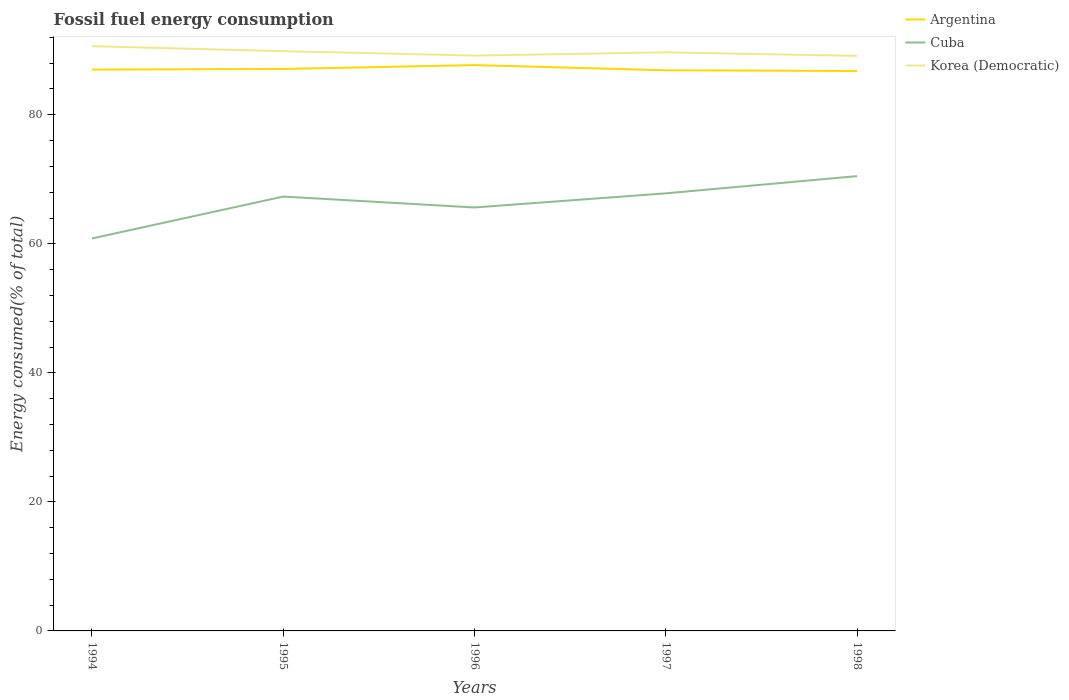Across all years, what is the maximum percentage of energy consumed in Cuba?
Offer a terse response. 60.83. What is the total percentage of energy consumed in Cuba in the graph?
Make the answer very short. -2.19. What is the difference between the highest and the second highest percentage of energy consumed in Korea (Democratic)?
Offer a terse response. 1.5. How many lines are there?
Provide a short and direct response. 3. How many legend labels are there?
Offer a very short reply. 3. What is the title of the graph?
Make the answer very short. Fossil fuel energy consumption. What is the label or title of the Y-axis?
Provide a short and direct response. Energy consumed(% of total). What is the Energy consumed(% of total) in Argentina in 1994?
Your answer should be very brief. 87.01. What is the Energy consumed(% of total) of Cuba in 1994?
Offer a terse response. 60.83. What is the Energy consumed(% of total) in Korea (Democratic) in 1994?
Make the answer very short. 90.63. What is the Energy consumed(% of total) in Argentina in 1995?
Provide a succinct answer. 87.1. What is the Energy consumed(% of total) of Cuba in 1995?
Ensure brevity in your answer.  67.32. What is the Energy consumed(% of total) of Korea (Democratic) in 1995?
Your answer should be compact. 89.86. What is the Energy consumed(% of total) in Argentina in 1996?
Your answer should be very brief. 87.7. What is the Energy consumed(% of total) in Cuba in 1996?
Offer a terse response. 65.63. What is the Energy consumed(% of total) of Korea (Democratic) in 1996?
Keep it short and to the point. 89.17. What is the Energy consumed(% of total) in Argentina in 1997?
Offer a terse response. 86.9. What is the Energy consumed(% of total) in Cuba in 1997?
Provide a succinct answer. 67.83. What is the Energy consumed(% of total) in Korea (Democratic) in 1997?
Offer a terse response. 89.68. What is the Energy consumed(% of total) of Argentina in 1998?
Your answer should be very brief. 86.79. What is the Energy consumed(% of total) of Cuba in 1998?
Give a very brief answer. 70.49. What is the Energy consumed(% of total) in Korea (Democratic) in 1998?
Provide a short and direct response. 89.13. Across all years, what is the maximum Energy consumed(% of total) in Argentina?
Your answer should be very brief. 87.7. Across all years, what is the maximum Energy consumed(% of total) of Cuba?
Offer a terse response. 70.49. Across all years, what is the maximum Energy consumed(% of total) in Korea (Democratic)?
Provide a succinct answer. 90.63. Across all years, what is the minimum Energy consumed(% of total) in Argentina?
Ensure brevity in your answer.  86.79. Across all years, what is the minimum Energy consumed(% of total) in Cuba?
Offer a very short reply. 60.83. Across all years, what is the minimum Energy consumed(% of total) in Korea (Democratic)?
Keep it short and to the point. 89.13. What is the total Energy consumed(% of total) of Argentina in the graph?
Your answer should be very brief. 435.5. What is the total Energy consumed(% of total) in Cuba in the graph?
Make the answer very short. 332.11. What is the total Energy consumed(% of total) in Korea (Democratic) in the graph?
Offer a very short reply. 448.48. What is the difference between the Energy consumed(% of total) in Argentina in 1994 and that in 1995?
Your answer should be compact. -0.09. What is the difference between the Energy consumed(% of total) in Cuba in 1994 and that in 1995?
Keep it short and to the point. -6.49. What is the difference between the Energy consumed(% of total) of Korea (Democratic) in 1994 and that in 1995?
Give a very brief answer. 0.77. What is the difference between the Energy consumed(% of total) in Argentina in 1994 and that in 1996?
Ensure brevity in your answer.  -0.69. What is the difference between the Energy consumed(% of total) of Cuba in 1994 and that in 1996?
Offer a very short reply. -4.8. What is the difference between the Energy consumed(% of total) of Korea (Democratic) in 1994 and that in 1996?
Offer a terse response. 1.46. What is the difference between the Energy consumed(% of total) in Argentina in 1994 and that in 1997?
Your answer should be very brief. 0.11. What is the difference between the Energy consumed(% of total) of Cuba in 1994 and that in 1997?
Ensure brevity in your answer.  -6.99. What is the difference between the Energy consumed(% of total) of Korea (Democratic) in 1994 and that in 1997?
Your response must be concise. 0.95. What is the difference between the Energy consumed(% of total) of Argentina in 1994 and that in 1998?
Provide a short and direct response. 0.22. What is the difference between the Energy consumed(% of total) in Cuba in 1994 and that in 1998?
Your response must be concise. -9.66. What is the difference between the Energy consumed(% of total) in Korea (Democratic) in 1994 and that in 1998?
Give a very brief answer. 1.5. What is the difference between the Energy consumed(% of total) in Argentina in 1995 and that in 1996?
Give a very brief answer. -0.6. What is the difference between the Energy consumed(% of total) in Cuba in 1995 and that in 1996?
Make the answer very short. 1.69. What is the difference between the Energy consumed(% of total) in Korea (Democratic) in 1995 and that in 1996?
Provide a short and direct response. 0.69. What is the difference between the Energy consumed(% of total) in Argentina in 1995 and that in 1997?
Your answer should be compact. 0.2. What is the difference between the Energy consumed(% of total) of Cuba in 1995 and that in 1997?
Give a very brief answer. -0.5. What is the difference between the Energy consumed(% of total) of Korea (Democratic) in 1995 and that in 1997?
Give a very brief answer. 0.18. What is the difference between the Energy consumed(% of total) of Argentina in 1995 and that in 1998?
Keep it short and to the point. 0.31. What is the difference between the Energy consumed(% of total) in Cuba in 1995 and that in 1998?
Your response must be concise. -3.17. What is the difference between the Energy consumed(% of total) of Korea (Democratic) in 1995 and that in 1998?
Give a very brief answer. 0.73. What is the difference between the Energy consumed(% of total) in Argentina in 1996 and that in 1997?
Offer a very short reply. 0.8. What is the difference between the Energy consumed(% of total) of Cuba in 1996 and that in 1997?
Provide a short and direct response. -2.19. What is the difference between the Energy consumed(% of total) of Korea (Democratic) in 1996 and that in 1997?
Make the answer very short. -0.51. What is the difference between the Energy consumed(% of total) of Argentina in 1996 and that in 1998?
Your answer should be compact. 0.91. What is the difference between the Energy consumed(% of total) in Cuba in 1996 and that in 1998?
Offer a very short reply. -4.86. What is the difference between the Energy consumed(% of total) in Korea (Democratic) in 1996 and that in 1998?
Make the answer very short. 0.04. What is the difference between the Energy consumed(% of total) in Argentina in 1997 and that in 1998?
Make the answer very short. 0.11. What is the difference between the Energy consumed(% of total) in Cuba in 1997 and that in 1998?
Offer a terse response. -2.67. What is the difference between the Energy consumed(% of total) in Korea (Democratic) in 1997 and that in 1998?
Your answer should be very brief. 0.54. What is the difference between the Energy consumed(% of total) of Argentina in 1994 and the Energy consumed(% of total) of Cuba in 1995?
Offer a very short reply. 19.69. What is the difference between the Energy consumed(% of total) in Argentina in 1994 and the Energy consumed(% of total) in Korea (Democratic) in 1995?
Ensure brevity in your answer.  -2.85. What is the difference between the Energy consumed(% of total) in Cuba in 1994 and the Energy consumed(% of total) in Korea (Democratic) in 1995?
Give a very brief answer. -29.03. What is the difference between the Energy consumed(% of total) in Argentina in 1994 and the Energy consumed(% of total) in Cuba in 1996?
Offer a very short reply. 21.38. What is the difference between the Energy consumed(% of total) in Argentina in 1994 and the Energy consumed(% of total) in Korea (Democratic) in 1996?
Your answer should be compact. -2.16. What is the difference between the Energy consumed(% of total) in Cuba in 1994 and the Energy consumed(% of total) in Korea (Democratic) in 1996?
Provide a succinct answer. -28.34. What is the difference between the Energy consumed(% of total) in Argentina in 1994 and the Energy consumed(% of total) in Cuba in 1997?
Offer a terse response. 19.19. What is the difference between the Energy consumed(% of total) of Argentina in 1994 and the Energy consumed(% of total) of Korea (Democratic) in 1997?
Ensure brevity in your answer.  -2.67. What is the difference between the Energy consumed(% of total) in Cuba in 1994 and the Energy consumed(% of total) in Korea (Democratic) in 1997?
Give a very brief answer. -28.85. What is the difference between the Energy consumed(% of total) in Argentina in 1994 and the Energy consumed(% of total) in Cuba in 1998?
Your answer should be compact. 16.52. What is the difference between the Energy consumed(% of total) of Argentina in 1994 and the Energy consumed(% of total) of Korea (Democratic) in 1998?
Your answer should be very brief. -2.12. What is the difference between the Energy consumed(% of total) of Cuba in 1994 and the Energy consumed(% of total) of Korea (Democratic) in 1998?
Keep it short and to the point. -28.3. What is the difference between the Energy consumed(% of total) of Argentina in 1995 and the Energy consumed(% of total) of Cuba in 1996?
Offer a terse response. 21.47. What is the difference between the Energy consumed(% of total) in Argentina in 1995 and the Energy consumed(% of total) in Korea (Democratic) in 1996?
Provide a short and direct response. -2.07. What is the difference between the Energy consumed(% of total) of Cuba in 1995 and the Energy consumed(% of total) of Korea (Democratic) in 1996?
Your answer should be compact. -21.85. What is the difference between the Energy consumed(% of total) of Argentina in 1995 and the Energy consumed(% of total) of Cuba in 1997?
Your answer should be very brief. 19.28. What is the difference between the Energy consumed(% of total) in Argentina in 1995 and the Energy consumed(% of total) in Korea (Democratic) in 1997?
Offer a very short reply. -2.58. What is the difference between the Energy consumed(% of total) of Cuba in 1995 and the Energy consumed(% of total) of Korea (Democratic) in 1997?
Your answer should be compact. -22.36. What is the difference between the Energy consumed(% of total) of Argentina in 1995 and the Energy consumed(% of total) of Cuba in 1998?
Offer a terse response. 16.61. What is the difference between the Energy consumed(% of total) of Argentina in 1995 and the Energy consumed(% of total) of Korea (Democratic) in 1998?
Offer a very short reply. -2.03. What is the difference between the Energy consumed(% of total) in Cuba in 1995 and the Energy consumed(% of total) in Korea (Democratic) in 1998?
Ensure brevity in your answer.  -21.81. What is the difference between the Energy consumed(% of total) of Argentina in 1996 and the Energy consumed(% of total) of Cuba in 1997?
Provide a succinct answer. 19.88. What is the difference between the Energy consumed(% of total) of Argentina in 1996 and the Energy consumed(% of total) of Korea (Democratic) in 1997?
Offer a very short reply. -1.98. What is the difference between the Energy consumed(% of total) of Cuba in 1996 and the Energy consumed(% of total) of Korea (Democratic) in 1997?
Your answer should be compact. -24.04. What is the difference between the Energy consumed(% of total) in Argentina in 1996 and the Energy consumed(% of total) in Cuba in 1998?
Give a very brief answer. 17.21. What is the difference between the Energy consumed(% of total) in Argentina in 1996 and the Energy consumed(% of total) in Korea (Democratic) in 1998?
Give a very brief answer. -1.43. What is the difference between the Energy consumed(% of total) of Cuba in 1996 and the Energy consumed(% of total) of Korea (Democratic) in 1998?
Ensure brevity in your answer.  -23.5. What is the difference between the Energy consumed(% of total) of Argentina in 1997 and the Energy consumed(% of total) of Cuba in 1998?
Provide a succinct answer. 16.4. What is the difference between the Energy consumed(% of total) of Argentina in 1997 and the Energy consumed(% of total) of Korea (Democratic) in 1998?
Make the answer very short. -2.24. What is the difference between the Energy consumed(% of total) of Cuba in 1997 and the Energy consumed(% of total) of Korea (Democratic) in 1998?
Your answer should be compact. -21.31. What is the average Energy consumed(% of total) in Argentina per year?
Keep it short and to the point. 87.1. What is the average Energy consumed(% of total) in Cuba per year?
Give a very brief answer. 66.42. What is the average Energy consumed(% of total) in Korea (Democratic) per year?
Ensure brevity in your answer.  89.7. In the year 1994, what is the difference between the Energy consumed(% of total) of Argentina and Energy consumed(% of total) of Cuba?
Your answer should be very brief. 26.18. In the year 1994, what is the difference between the Energy consumed(% of total) in Argentina and Energy consumed(% of total) in Korea (Democratic)?
Your answer should be very brief. -3.62. In the year 1994, what is the difference between the Energy consumed(% of total) in Cuba and Energy consumed(% of total) in Korea (Democratic)?
Provide a succinct answer. -29.8. In the year 1995, what is the difference between the Energy consumed(% of total) of Argentina and Energy consumed(% of total) of Cuba?
Keep it short and to the point. 19.78. In the year 1995, what is the difference between the Energy consumed(% of total) in Argentina and Energy consumed(% of total) in Korea (Democratic)?
Offer a very short reply. -2.76. In the year 1995, what is the difference between the Energy consumed(% of total) of Cuba and Energy consumed(% of total) of Korea (Democratic)?
Provide a short and direct response. -22.54. In the year 1996, what is the difference between the Energy consumed(% of total) of Argentina and Energy consumed(% of total) of Cuba?
Keep it short and to the point. 22.07. In the year 1996, what is the difference between the Energy consumed(% of total) in Argentina and Energy consumed(% of total) in Korea (Democratic)?
Keep it short and to the point. -1.47. In the year 1996, what is the difference between the Energy consumed(% of total) of Cuba and Energy consumed(% of total) of Korea (Democratic)?
Offer a terse response. -23.54. In the year 1997, what is the difference between the Energy consumed(% of total) of Argentina and Energy consumed(% of total) of Cuba?
Provide a short and direct response. 19.07. In the year 1997, what is the difference between the Energy consumed(% of total) of Argentina and Energy consumed(% of total) of Korea (Democratic)?
Offer a very short reply. -2.78. In the year 1997, what is the difference between the Energy consumed(% of total) of Cuba and Energy consumed(% of total) of Korea (Democratic)?
Offer a terse response. -21.85. In the year 1998, what is the difference between the Energy consumed(% of total) of Argentina and Energy consumed(% of total) of Cuba?
Keep it short and to the point. 16.3. In the year 1998, what is the difference between the Energy consumed(% of total) in Argentina and Energy consumed(% of total) in Korea (Democratic)?
Provide a succinct answer. -2.34. In the year 1998, what is the difference between the Energy consumed(% of total) in Cuba and Energy consumed(% of total) in Korea (Democratic)?
Keep it short and to the point. -18.64. What is the ratio of the Energy consumed(% of total) of Argentina in 1994 to that in 1995?
Offer a very short reply. 1. What is the ratio of the Energy consumed(% of total) of Cuba in 1994 to that in 1995?
Your response must be concise. 0.9. What is the ratio of the Energy consumed(% of total) in Korea (Democratic) in 1994 to that in 1995?
Offer a very short reply. 1.01. What is the ratio of the Energy consumed(% of total) in Cuba in 1994 to that in 1996?
Your answer should be compact. 0.93. What is the ratio of the Energy consumed(% of total) in Korea (Democratic) in 1994 to that in 1996?
Give a very brief answer. 1.02. What is the ratio of the Energy consumed(% of total) in Argentina in 1994 to that in 1997?
Offer a terse response. 1. What is the ratio of the Energy consumed(% of total) of Cuba in 1994 to that in 1997?
Your answer should be very brief. 0.9. What is the ratio of the Energy consumed(% of total) of Korea (Democratic) in 1994 to that in 1997?
Your answer should be compact. 1.01. What is the ratio of the Energy consumed(% of total) of Argentina in 1994 to that in 1998?
Provide a short and direct response. 1. What is the ratio of the Energy consumed(% of total) of Cuba in 1994 to that in 1998?
Make the answer very short. 0.86. What is the ratio of the Energy consumed(% of total) in Korea (Democratic) in 1994 to that in 1998?
Offer a terse response. 1.02. What is the ratio of the Energy consumed(% of total) in Cuba in 1995 to that in 1996?
Your answer should be very brief. 1.03. What is the ratio of the Energy consumed(% of total) in Korea (Democratic) in 1995 to that in 1996?
Keep it short and to the point. 1.01. What is the ratio of the Energy consumed(% of total) of Argentina in 1995 to that in 1997?
Ensure brevity in your answer.  1. What is the ratio of the Energy consumed(% of total) of Cuba in 1995 to that in 1997?
Your response must be concise. 0.99. What is the ratio of the Energy consumed(% of total) of Korea (Democratic) in 1995 to that in 1997?
Give a very brief answer. 1. What is the ratio of the Energy consumed(% of total) in Argentina in 1995 to that in 1998?
Your answer should be very brief. 1. What is the ratio of the Energy consumed(% of total) of Cuba in 1995 to that in 1998?
Offer a terse response. 0.95. What is the ratio of the Energy consumed(% of total) of Korea (Democratic) in 1995 to that in 1998?
Ensure brevity in your answer.  1.01. What is the ratio of the Energy consumed(% of total) in Argentina in 1996 to that in 1997?
Provide a short and direct response. 1.01. What is the ratio of the Energy consumed(% of total) of Cuba in 1996 to that in 1997?
Your answer should be very brief. 0.97. What is the ratio of the Energy consumed(% of total) of Korea (Democratic) in 1996 to that in 1997?
Your response must be concise. 0.99. What is the ratio of the Energy consumed(% of total) in Argentina in 1996 to that in 1998?
Your answer should be very brief. 1.01. What is the ratio of the Energy consumed(% of total) of Cuba in 1996 to that in 1998?
Offer a very short reply. 0.93. What is the ratio of the Energy consumed(% of total) of Korea (Democratic) in 1996 to that in 1998?
Your answer should be compact. 1. What is the ratio of the Energy consumed(% of total) in Argentina in 1997 to that in 1998?
Your answer should be compact. 1. What is the ratio of the Energy consumed(% of total) in Cuba in 1997 to that in 1998?
Offer a very short reply. 0.96. What is the ratio of the Energy consumed(% of total) in Korea (Democratic) in 1997 to that in 1998?
Give a very brief answer. 1.01. What is the difference between the highest and the second highest Energy consumed(% of total) in Argentina?
Provide a succinct answer. 0.6. What is the difference between the highest and the second highest Energy consumed(% of total) of Cuba?
Your answer should be very brief. 2.67. What is the difference between the highest and the second highest Energy consumed(% of total) in Korea (Democratic)?
Ensure brevity in your answer.  0.77. What is the difference between the highest and the lowest Energy consumed(% of total) in Argentina?
Your response must be concise. 0.91. What is the difference between the highest and the lowest Energy consumed(% of total) of Cuba?
Provide a succinct answer. 9.66. What is the difference between the highest and the lowest Energy consumed(% of total) in Korea (Democratic)?
Offer a terse response. 1.5. 